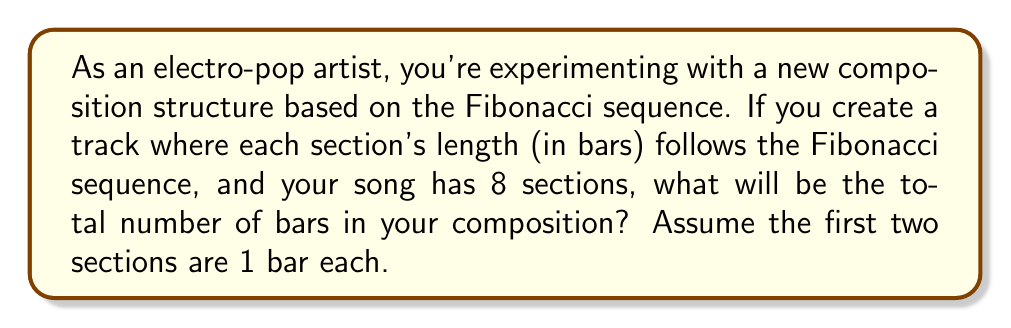Provide a solution to this math problem. Let's approach this step-by-step:

1) First, recall the Fibonacci sequence. It starts with 1, 1, and each subsequent number is the sum of the two preceding ones. So the sequence begins:

   1, 1, 2, 3, 5, 8, 13, 21, ...

2) In this case, we need the first 8 terms of the sequence, as the song has 8 sections:

   1, 1, 2, 3, 5, 8, 13, 21

3) To find the total number of bars, we need to sum these 8 terms:

   $$\sum_{i=1}^{8} F_i = 1 + 1 + 2 + 3 + 5 + 8 + 13 + 21$$

4) We can calculate this sum:

   $$1 + 1 + 2 + 3 + 5 + 8 + 13 + 21 = 54$$

5) Interestingly, there's a formula for the sum of Fibonacci numbers:

   $$\sum_{i=1}^{n} F_i = F_{n+2} - 1$$

   Where $F_n$ is the nth Fibonacci number.

6) We can verify this:
   
   $F_{10} = 55$ (the 10th Fibonacci number)
   $F_{10} - 1 = 55 - 1 = 54$

Thus, the total number of bars in the composition would be 54.
Answer: 54 bars 